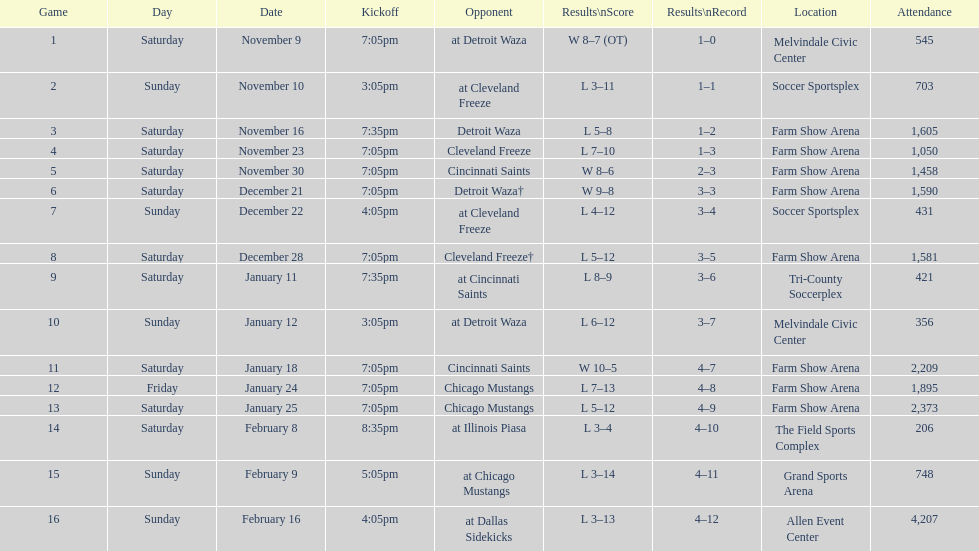Parse the table in full. {'header': ['Game', 'Day', 'Date', 'Kickoff', 'Opponent', 'Results\\nScore', 'Results\\nRecord', 'Location', 'Attendance'], 'rows': [['1', 'Saturday', 'November 9', '7:05pm', 'at Detroit Waza', 'W 8–7 (OT)', '1–0', 'Melvindale Civic Center', '545'], ['2', 'Sunday', 'November 10', '3:05pm', 'at Cleveland Freeze', 'L 3–11', '1–1', 'Soccer Sportsplex', '703'], ['3', 'Saturday', 'November 16', '7:35pm', 'Detroit Waza', 'L 5–8', '1–2', 'Farm Show Arena', '1,605'], ['4', 'Saturday', 'November 23', '7:05pm', 'Cleveland Freeze', 'L 7–10', '1–3', 'Farm Show Arena', '1,050'], ['5', 'Saturday', 'November 30', '7:05pm', 'Cincinnati Saints', 'W 8–6', '2–3', 'Farm Show Arena', '1,458'], ['6', 'Saturday', 'December 21', '7:05pm', 'Detroit Waza†', 'W 9–8', '3–3', 'Farm Show Arena', '1,590'], ['7', 'Sunday', 'December 22', '4:05pm', 'at Cleveland Freeze', 'L 4–12', '3–4', 'Soccer Sportsplex', '431'], ['8', 'Saturday', 'December 28', '7:05pm', 'Cleveland Freeze†', 'L 5–12', '3–5', 'Farm Show Arena', '1,581'], ['9', 'Saturday', 'January 11', '7:35pm', 'at Cincinnati Saints', 'L 8–9', '3–6', 'Tri-County Soccerplex', '421'], ['10', 'Sunday', 'January 12', '3:05pm', 'at Detroit Waza', 'L 6–12', '3–7', 'Melvindale Civic Center', '356'], ['11', 'Saturday', 'January 18', '7:05pm', 'Cincinnati Saints', 'W 10–5', '4–7', 'Farm Show Arena', '2,209'], ['12', 'Friday', 'January 24', '7:05pm', 'Chicago Mustangs', 'L 7–13', '4–8', 'Farm Show Arena', '1,895'], ['13', 'Saturday', 'January 25', '7:05pm', 'Chicago Mustangs', 'L 5–12', '4–9', 'Farm Show Arena', '2,373'], ['14', 'Saturday', 'February 8', '8:35pm', 'at Illinois Piasa', 'L 3–4', '4–10', 'The Field Sports Complex', '206'], ['15', 'Sunday', 'February 9', '5:05pm', 'at Chicago Mustangs', 'L 3–14', '4–11', 'Grand Sports Arena', '748'], ['16', 'Sunday', 'February 16', '4:05pm', 'at Dallas Sidekicks', 'L 3–13', '4–12', 'Allen Event Center', '4,207']]} What is the date of the game after december 22? December 28. 